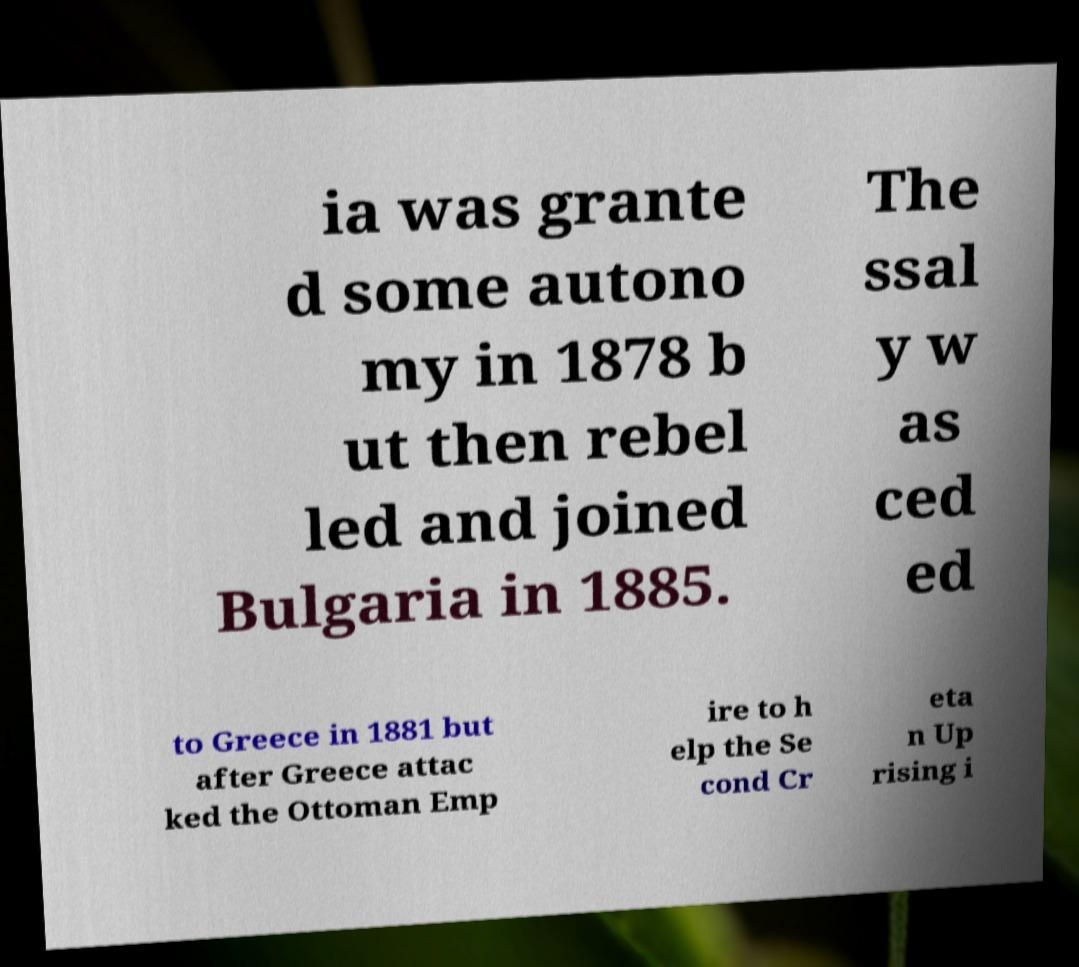I need the written content from this picture converted into text. Can you do that? ia was grante d some autono my in 1878 b ut then rebel led and joined Bulgaria in 1885. The ssal y w as ced ed to Greece in 1881 but after Greece attac ked the Ottoman Emp ire to h elp the Se cond Cr eta n Up rising i 